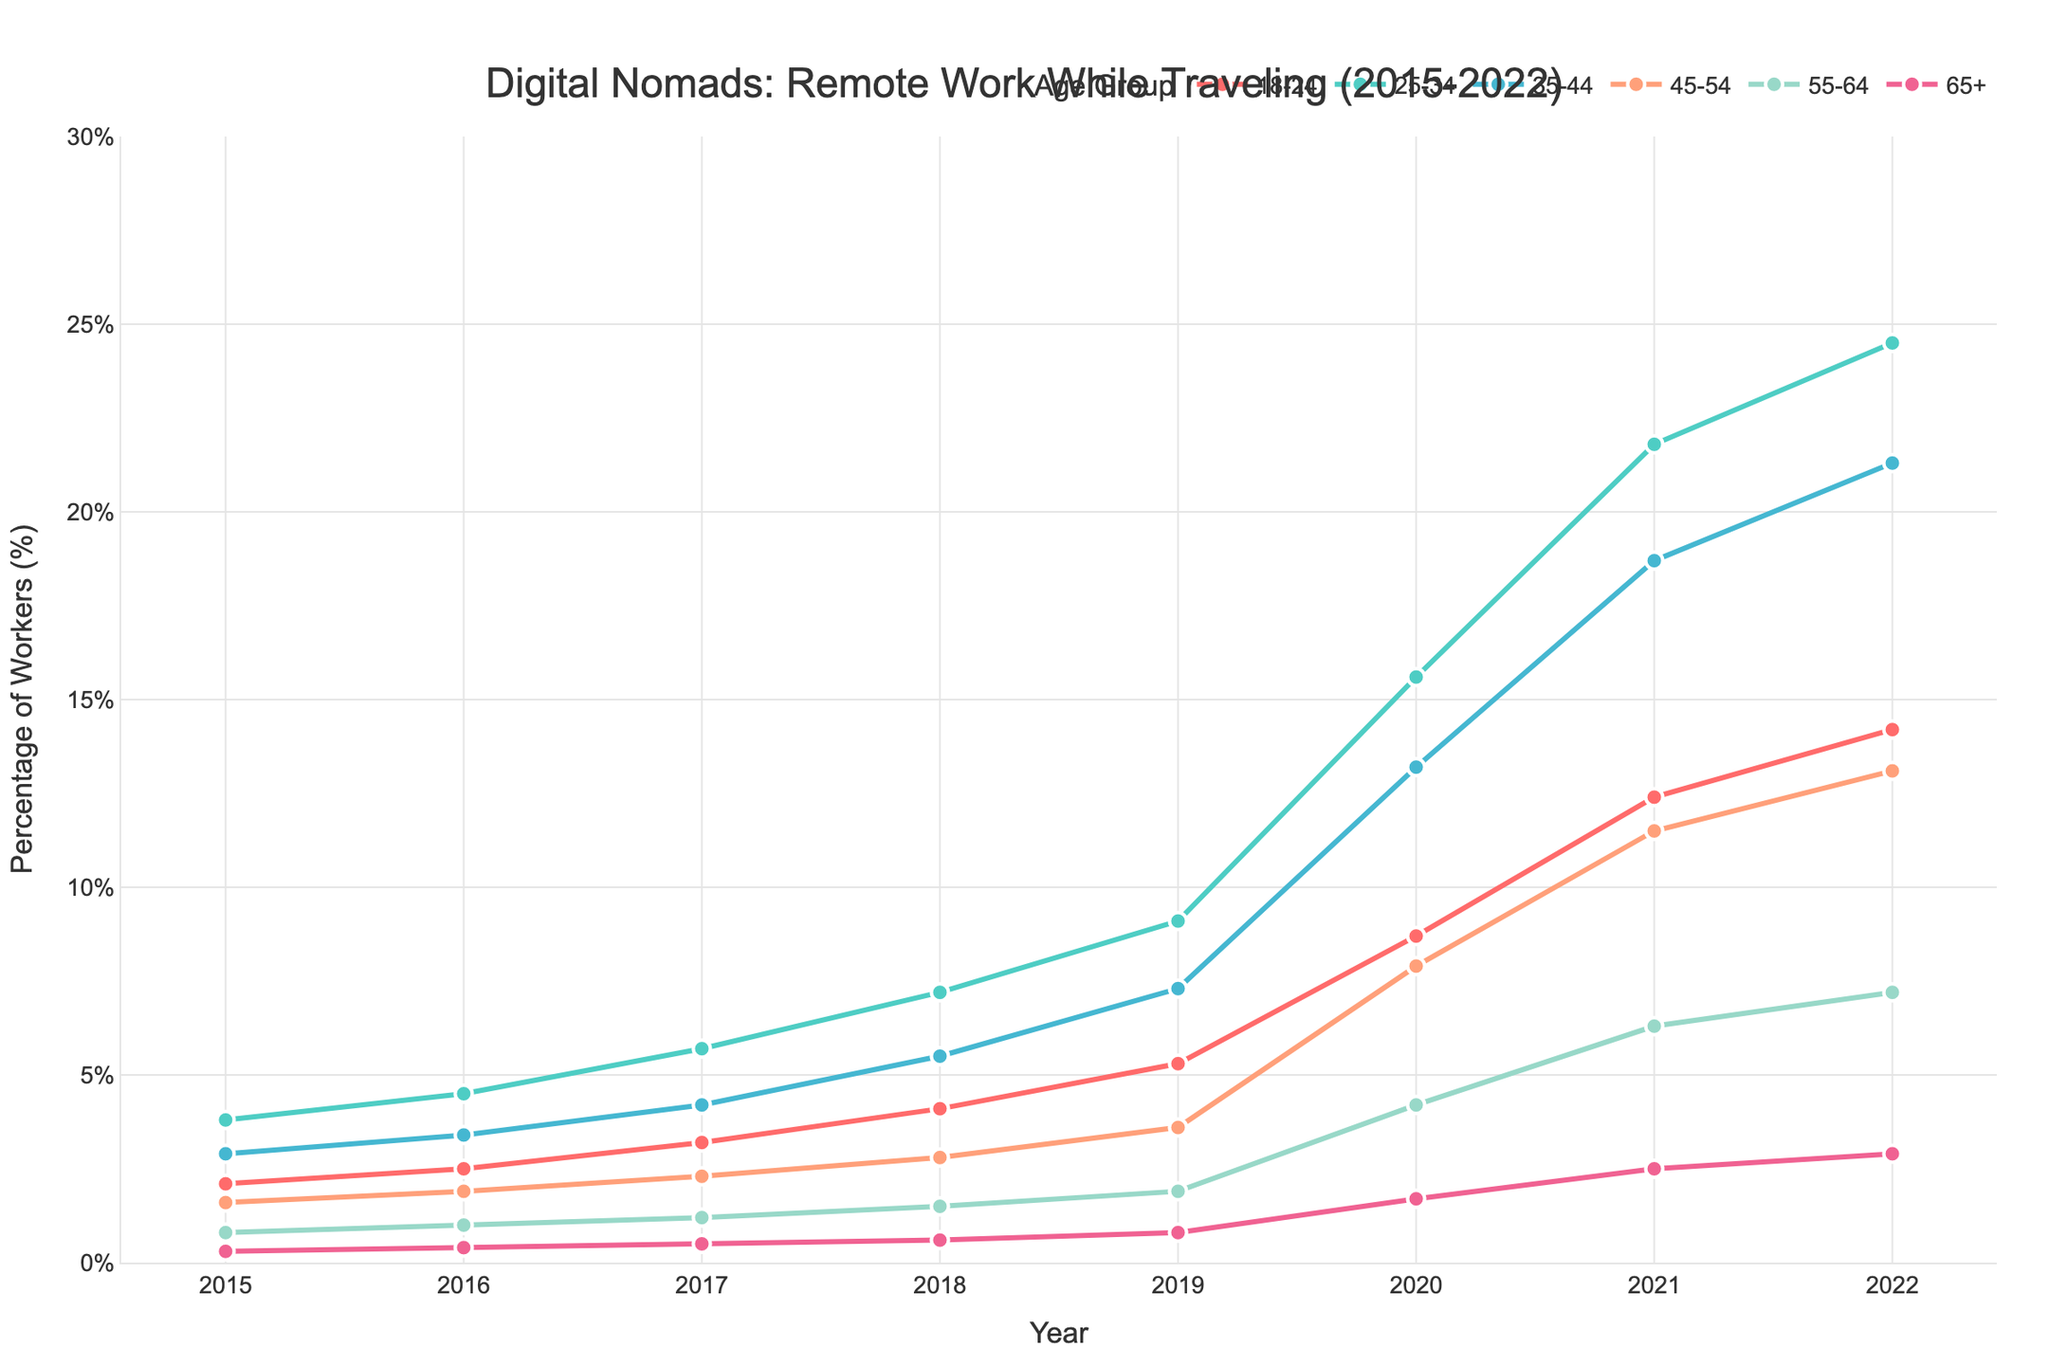What age group had the highest percentage of remote workers in 2022? By observing the chart, find the highest point on the y-axis for each age group in 2022. The 25-34 age group reaches approximately 24.5%, which is the highest among other age groups.
Answer: 25-34 What was the percentage increase in remote workers for the 18-24 age group from 2015 to 2022? The percentage in 2015 for the 18-24 age group was 2.1, and it increased to 14.2 in 2022. The increase is 14.2 - 2.1 = 12.1.
Answer: 12.1% Between which two consecutive years did the 25-34 age group see the largest increase in remote workers? Look for the steepest line segment for the 25-34 age group on the chart. The largest increase happens from 2019 to 2020, jumping from approximately 9.1 to 15.6.
Answer: 2019-2020 What was the percentage of remote workers for the 45-54 age group in 2017 and how does it compare to the 55-64 age group in the same year? In 2017, the percentage for the 45-54 age group is 2.3, while for the 55-64 age group it is 1.2. Comparing them: 2.3 > 1.2.
Answer: 45-54 was higher Which age group had the smallest increase in remote work percentage from 2019 to 2020? Subtract the 2019 value from the 2020 value for each age group and find the smallest difference. The smallest increase is for the 65+ age group, with an increase from 0.8 to 1.7, which is 0.9.
Answer: 65+ What is the average percentage of remote workers for the 35-44 age group from 2015 to 2022? Sum the percentages for the 35-44 age group (2.9 + 3.4 + 4.2 + 5.5 + 7.3 + 13.2 + 18.7 + 21.3) and divide by the number of years (8). The total is 76.5, and the average is 76.5 / 8 = 9.56.
Answer: 9.56% How does the percentage of remote workers for the 18-24 age group in 2022 compare to the 25-34 age group in 2018? The percentage for the 18-24 age group in 2022 is 14.2, while for the 25-34 age group in 2018 it is 7.2. Comparing them: 14.2 > 7.2.
Answer: 18-24 was higher Which age group had the most consistent increase in remote workers from 2015 to 2022? Observing the slopes of the lines, the 25-34 age group shows a relatively consistent upward trend without sharp fluctuations.
Answer: 25-34 What was the difference in the percentage of remote workers between the 35-44 and 45-54 age groups in 2021? The percentage for the 35-44 age group in 2021 was 18.7, while for the 45-54 age group it was 11.5. The difference is 18.7 - 11.5 = 7.2.
Answer: 7.2 